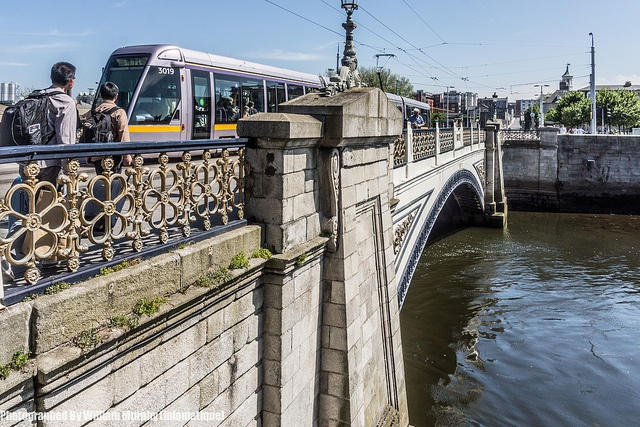Describe the objects in this image and their specific colors. I can see bus in lightblue, black, lightgray, gray, and darkgray tones, suitcase in lightblue, maroon, black, gray, and lightgray tones, people in lightblue, black, gray, tan, and darkgray tones, people in lightblue, black, lightgray, gray, and darkgray tones, and backpack in lightblue, black, gray, and darkgray tones in this image. 